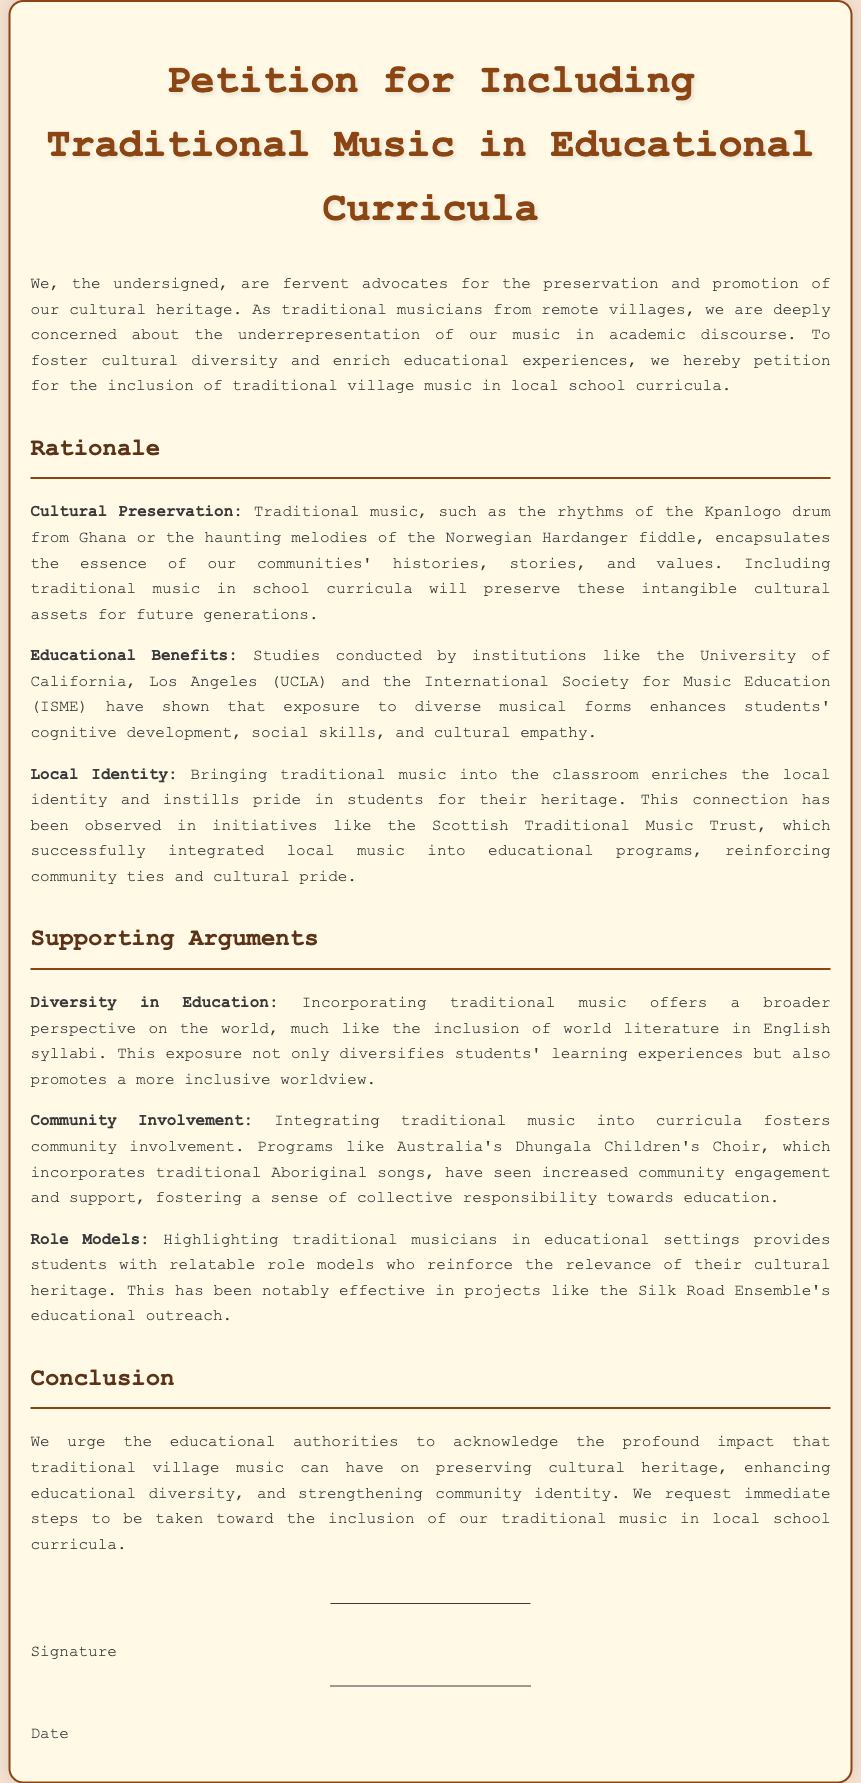What is the title of the petition? The title of the petition is stated at the top of the document, which addresses its purpose.
Answer: Petition for Including Traditional Music in Educational Curricula What does the petition advocate for? The petition advocates for the inclusion of traditional village music in local school curricula, aiming to promote cultural heritage.
Answer: Inclusion of traditional village music What is one example of traditional music mentioned? The document provides specific examples of traditional music, illustrating the diversity in cultural heritage.
Answer: Kpanlogo drum Which two institutions conducted studies supporting the benefits of diverse musical forms? The petition references studies from specific institutions that support its claims about educational benefits.
Answer: UCLA and ISME What community initiative is mentioned as a successful example of integrating local music? The petition highlights initiatives that have positively impacted local identity and cultural pride through educational programs.
Answer: Scottish Traditional Music Trust What is one educational benefit of including traditional music cited in the document? The document cites specific benefits of exposure to diverse musical forms that enhance student skills and understanding.
Answer: Cognitive development What is the overall conclusion the petition urges educational authorities to take? The conclusion summarizes the primary request made to educational authorities regarding action on this issue.
Answer: Acknowledge the impact of traditional village music What type of involvement does integrating traditional music into curricula foster? The document highlights the positive effects on community engagement when local music is incorporated into education.
Answer: Community involvement What is suggested as a way to provide students with relatable figures? The document highlights the importance of representation in educational settings through the inclusion of specific individuals.
Answer: Traditional musicians 